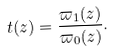Convert formula to latex. <formula><loc_0><loc_0><loc_500><loc_500>t ( z ) = \frac { \varpi _ { 1 } ( z ) } { \varpi _ { 0 } ( z ) } .</formula> 